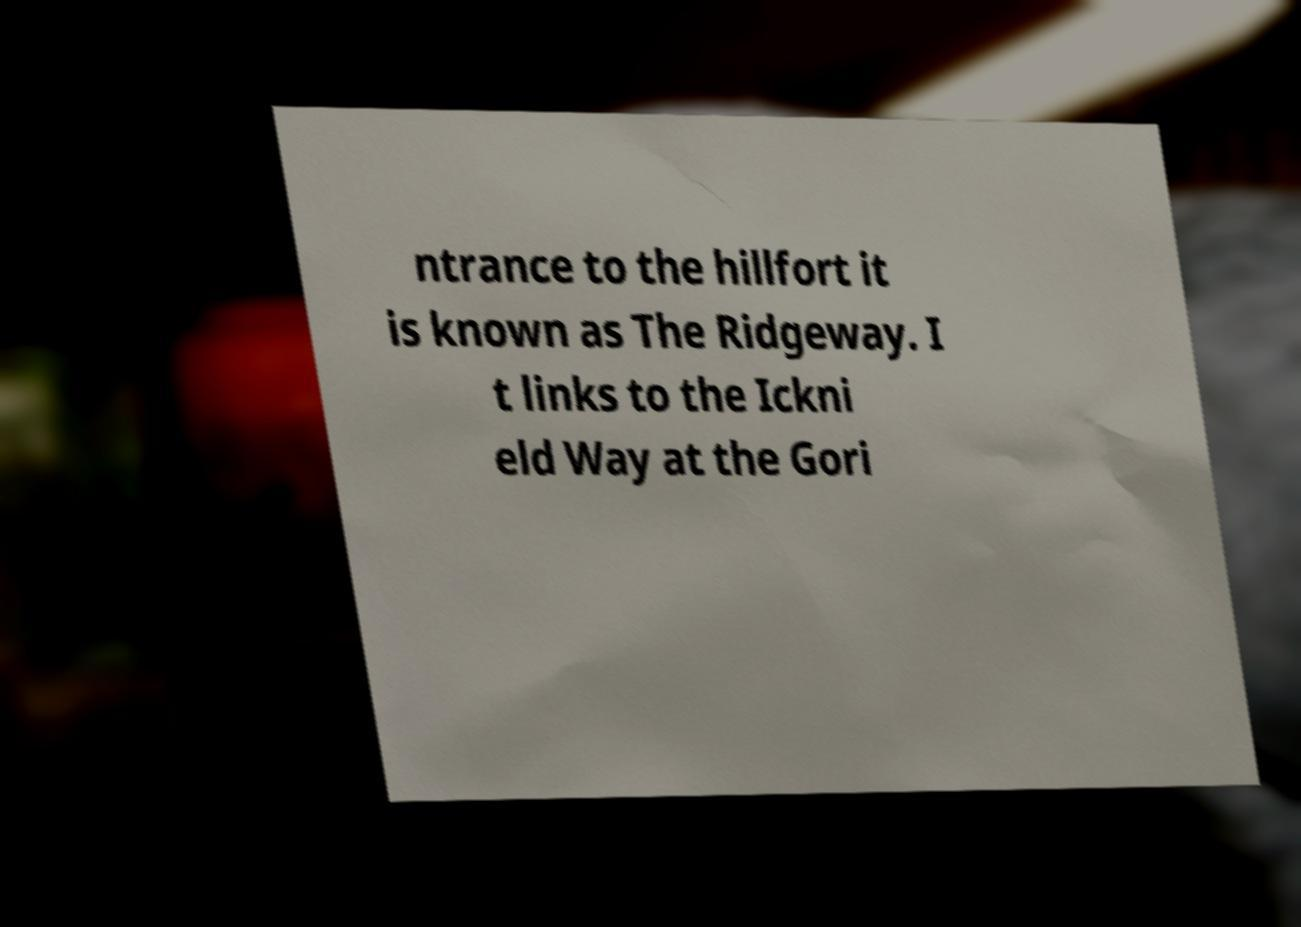Please read and relay the text visible in this image. What does it say? ntrance to the hillfort it is known as The Ridgeway. I t links to the Ickni eld Way at the Gori 